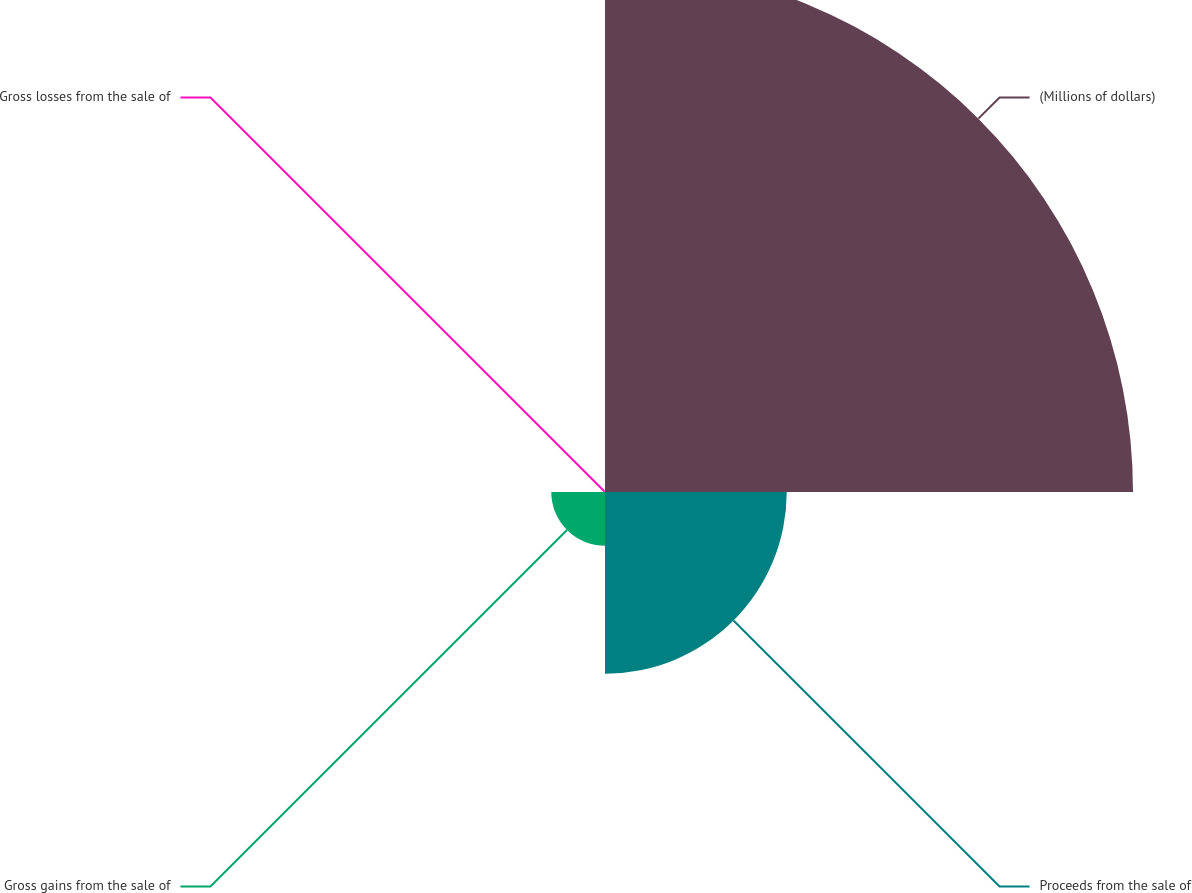<chart> <loc_0><loc_0><loc_500><loc_500><pie_chart><fcel>(Millions of dollars)<fcel>Proceeds from the sale of<fcel>Gross gains from the sale of<fcel>Gross losses from the sale of<nl><fcel>69.06%<fcel>23.77%<fcel>7.03%<fcel>0.14%<nl></chart> 